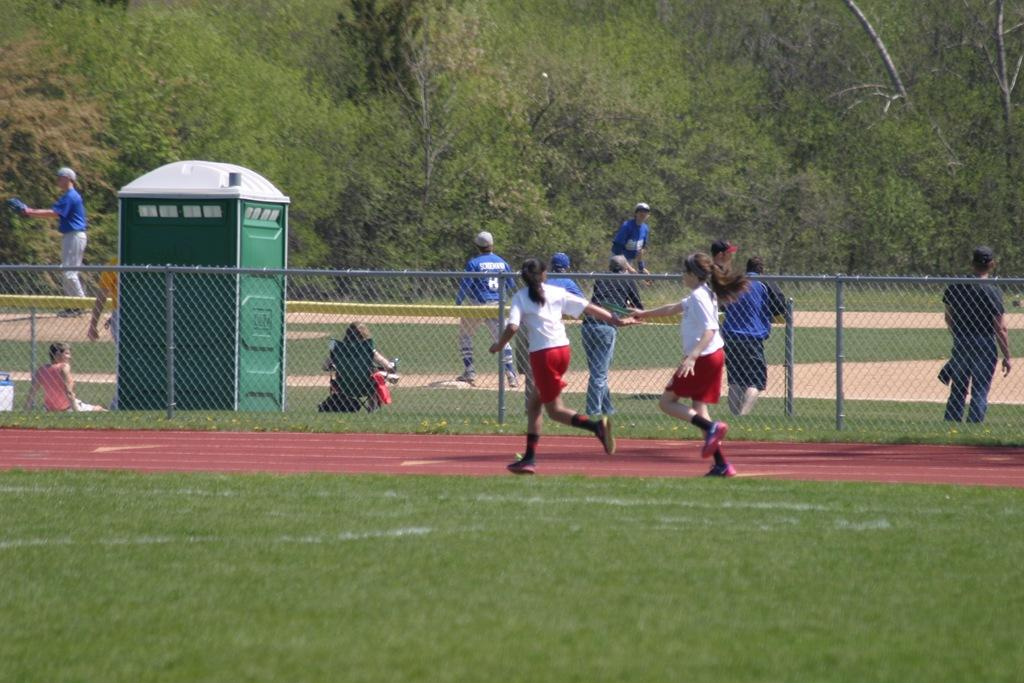How many people are present in the image? There are many people in the image. What are the people doing in the image? The people are playing in the ground. What can be seen in the middle of the image? There is a fence and a booth in the middle of the image. What is visible in the background of the image? There is a mountain in the background of the image, and it is covered with trees. What type of disease is present in the image? There is no mention of a disease or a twig in the image. The image features people playing in the ground, a fence, a booth, a mountain, and trees. 